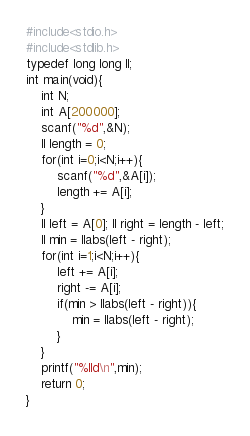Convert code to text. <code><loc_0><loc_0><loc_500><loc_500><_C_>#include<stdio.h>
#include<stdlib.h>
typedef long long ll;
int main(void){
    int N;
    int A[200000];
    scanf("%d",&N);
    ll length = 0;
    for(int i=0;i<N;i++){
        scanf("%d",&A[i]);
        length += A[i];
    }
    ll left = A[0]; ll right = length - left;
    ll min = llabs(left - right);
    for(int i=1;i<N;i++){
        left += A[i];
        right -= A[i];
        if(min > llabs(left - right)){
            min = llabs(left - right);
        }
    }
    printf("%lld\n",min);
    return 0;
}
</code> 